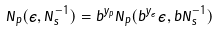<formula> <loc_0><loc_0><loc_500><loc_500>N _ { p } ( \epsilon , N _ { s } ^ { - 1 } ) = b ^ { y _ { p } } N _ { p } ( b ^ { y _ { \epsilon } } \epsilon , b N _ { s } ^ { - 1 } )</formula> 